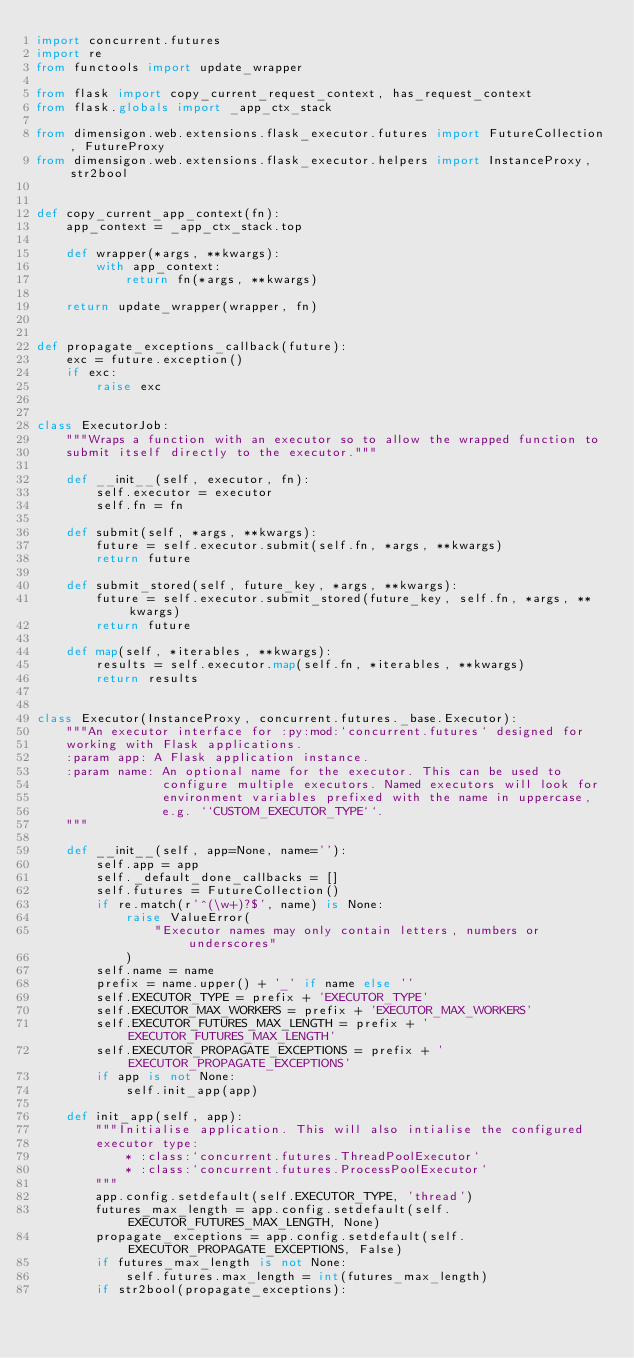<code> <loc_0><loc_0><loc_500><loc_500><_Python_>import concurrent.futures
import re
from functools import update_wrapper

from flask import copy_current_request_context, has_request_context
from flask.globals import _app_ctx_stack

from dimensigon.web.extensions.flask_executor.futures import FutureCollection, FutureProxy
from dimensigon.web.extensions.flask_executor.helpers import InstanceProxy, str2bool


def copy_current_app_context(fn):
    app_context = _app_ctx_stack.top

    def wrapper(*args, **kwargs):
        with app_context:
            return fn(*args, **kwargs)

    return update_wrapper(wrapper, fn)


def propagate_exceptions_callback(future):
    exc = future.exception()
    if exc:
        raise exc


class ExecutorJob:
    """Wraps a function with an executor so to allow the wrapped function to
    submit itself directly to the executor."""

    def __init__(self, executor, fn):
        self.executor = executor
        self.fn = fn

    def submit(self, *args, **kwargs):
        future = self.executor.submit(self.fn, *args, **kwargs)
        return future

    def submit_stored(self, future_key, *args, **kwargs):
        future = self.executor.submit_stored(future_key, self.fn, *args, **kwargs)
        return future

    def map(self, *iterables, **kwargs):
        results = self.executor.map(self.fn, *iterables, **kwargs)
        return results


class Executor(InstanceProxy, concurrent.futures._base.Executor):
    """An executor interface for :py:mod:`concurrent.futures` designed for
    working with Flask applications.
    :param app: A Flask application instance.
    :param name: An optional name for the executor. This can be used to
                 configure multiple executors. Named executors will look for
                 environment variables prefixed with the name in uppercase,
                 e.g. ``CUSTOM_EXECUTOR_TYPE``.
    """

    def __init__(self, app=None, name=''):
        self.app = app
        self._default_done_callbacks = []
        self.futures = FutureCollection()
        if re.match(r'^(\w+)?$', name) is None:
            raise ValueError(
                "Executor names may only contain letters, numbers or underscores"
            )
        self.name = name
        prefix = name.upper() + '_' if name else ''
        self.EXECUTOR_TYPE = prefix + 'EXECUTOR_TYPE'
        self.EXECUTOR_MAX_WORKERS = prefix + 'EXECUTOR_MAX_WORKERS'
        self.EXECUTOR_FUTURES_MAX_LENGTH = prefix + 'EXECUTOR_FUTURES_MAX_LENGTH'
        self.EXECUTOR_PROPAGATE_EXCEPTIONS = prefix + 'EXECUTOR_PROPAGATE_EXCEPTIONS'
        if app is not None:
            self.init_app(app)

    def init_app(self, app):
        """Initialise application. This will also intialise the configured
        executor type:
            * :class:`concurrent.futures.ThreadPoolExecutor`
            * :class:`concurrent.futures.ProcessPoolExecutor`
        """
        app.config.setdefault(self.EXECUTOR_TYPE, 'thread')
        futures_max_length = app.config.setdefault(self.EXECUTOR_FUTURES_MAX_LENGTH, None)
        propagate_exceptions = app.config.setdefault(self.EXECUTOR_PROPAGATE_EXCEPTIONS, False)
        if futures_max_length is not None:
            self.futures.max_length = int(futures_max_length)
        if str2bool(propagate_exceptions):</code> 